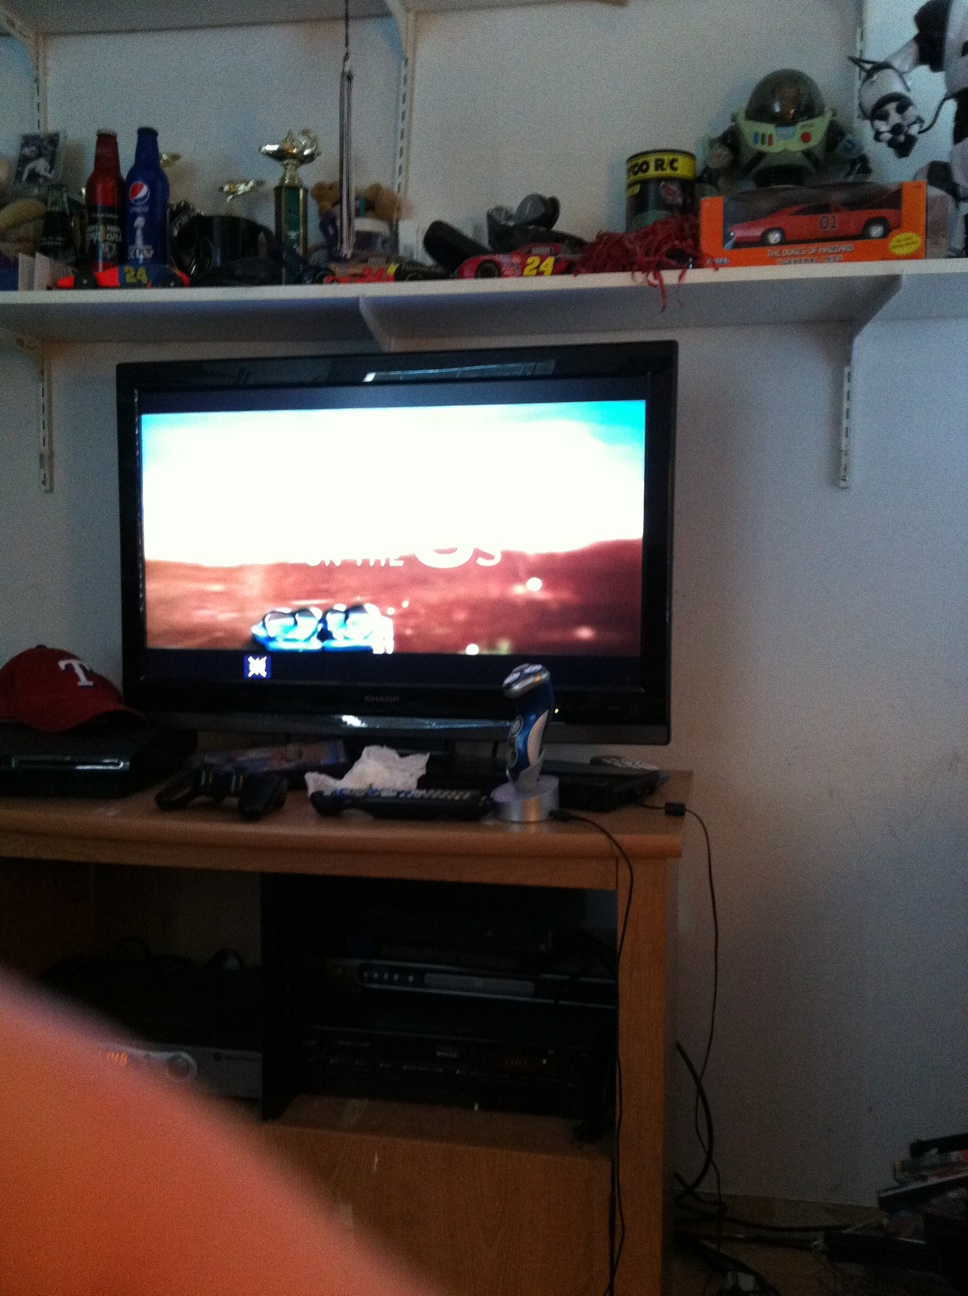Can you describe some of the objects on the shelf above the TV? The shelf above the TV holds a variety of items, including several toy cars, a couple of trophies, a Pepsi bottle, and some other decorative objects. 